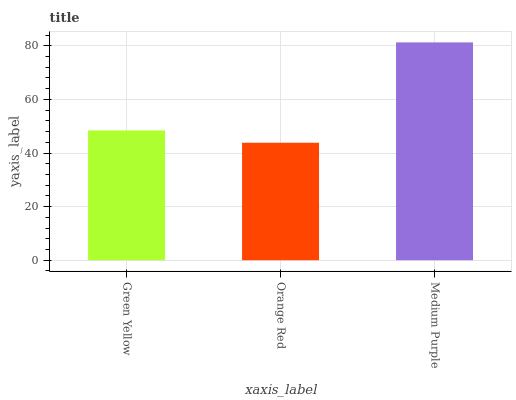Is Orange Red the minimum?
Answer yes or no. Yes. Is Medium Purple the maximum?
Answer yes or no. Yes. Is Medium Purple the minimum?
Answer yes or no. No. Is Orange Red the maximum?
Answer yes or no. No. Is Medium Purple greater than Orange Red?
Answer yes or no. Yes. Is Orange Red less than Medium Purple?
Answer yes or no. Yes. Is Orange Red greater than Medium Purple?
Answer yes or no. No. Is Medium Purple less than Orange Red?
Answer yes or no. No. Is Green Yellow the high median?
Answer yes or no. Yes. Is Green Yellow the low median?
Answer yes or no. Yes. Is Orange Red the high median?
Answer yes or no. No. Is Medium Purple the low median?
Answer yes or no. No. 